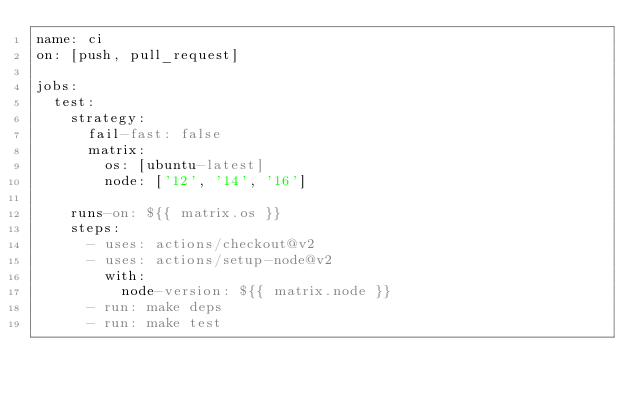<code> <loc_0><loc_0><loc_500><loc_500><_YAML_>name: ci
on: [push, pull_request]

jobs:
  test:
    strategy:
      fail-fast: false
      matrix:
        os: [ubuntu-latest]
        node: ['12', '14', '16']

    runs-on: ${{ matrix.os }}
    steps:
      - uses: actions/checkout@v2
      - uses: actions/setup-node@v2
        with:
          node-version: ${{ matrix.node }}
      - run: make deps
      - run: make test

</code> 